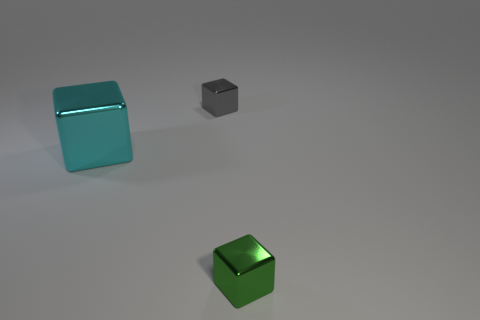Add 1 rubber balls. How many objects exist? 4 Subtract all small blue cylinders. Subtract all large cyan metallic cubes. How many objects are left? 2 Add 2 gray things. How many gray things are left? 3 Add 3 yellow shiny spheres. How many yellow shiny spheres exist? 3 Subtract 0 red cylinders. How many objects are left? 3 